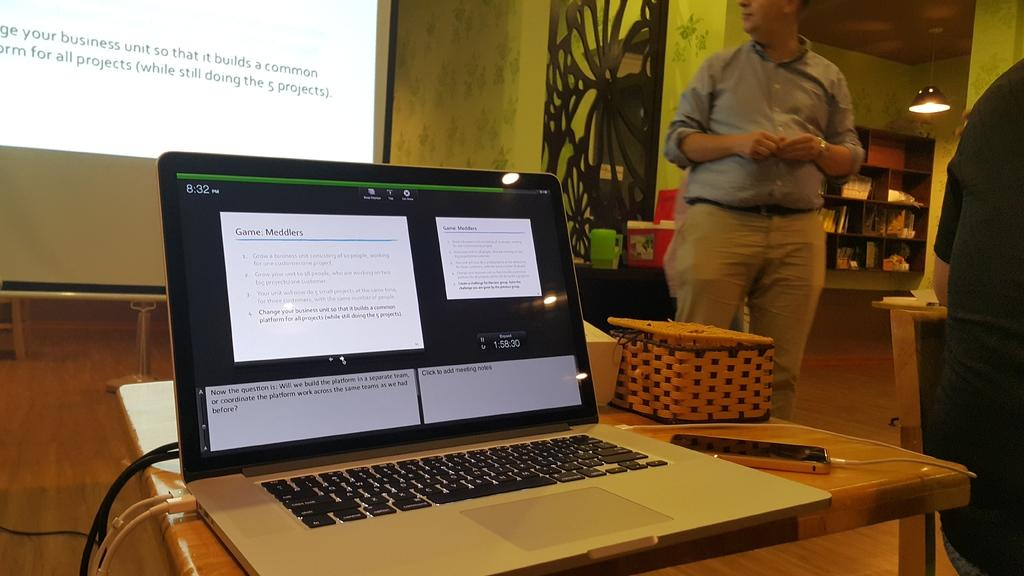What electronic device is visible in the image? There is a laptop in the image. What other electronic device can be seen in the image? There is a phone in the image. What is being displayed on the screen in the image? There is a projector's screen in the image. Can you describe the people in the image? There are people standing in the image. What type of heart is being displayed on the projector's screen? There is no heart displayed on the projector's screen in the image. What caption can be seen under the laptop in the image? There is no caption visible under the laptop in the image. 